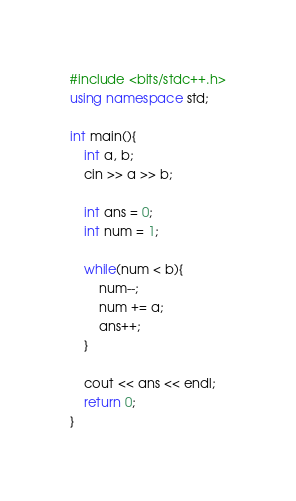<code> <loc_0><loc_0><loc_500><loc_500><_C++_>#include <bits/stdc++.h>
using namespace std;

int main(){
    int a, b;
    cin >> a >> b;

    int ans = 0;
    int num = 1;

    while(num < b){
        num--;
        num += a;
        ans++;
    }

    cout << ans << endl;
    return 0;
}</code> 